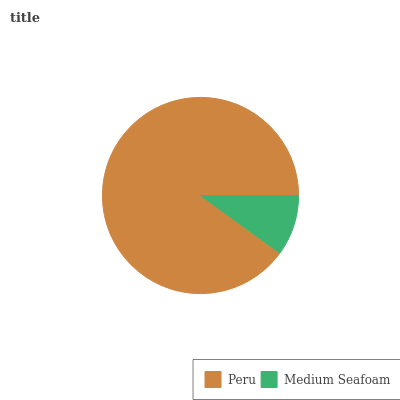Is Medium Seafoam the minimum?
Answer yes or no. Yes. Is Peru the maximum?
Answer yes or no. Yes. Is Medium Seafoam the maximum?
Answer yes or no. No. Is Peru greater than Medium Seafoam?
Answer yes or no. Yes. Is Medium Seafoam less than Peru?
Answer yes or no. Yes. Is Medium Seafoam greater than Peru?
Answer yes or no. No. Is Peru less than Medium Seafoam?
Answer yes or no. No. Is Peru the high median?
Answer yes or no. Yes. Is Medium Seafoam the low median?
Answer yes or no. Yes. Is Medium Seafoam the high median?
Answer yes or no. No. Is Peru the low median?
Answer yes or no. No. 